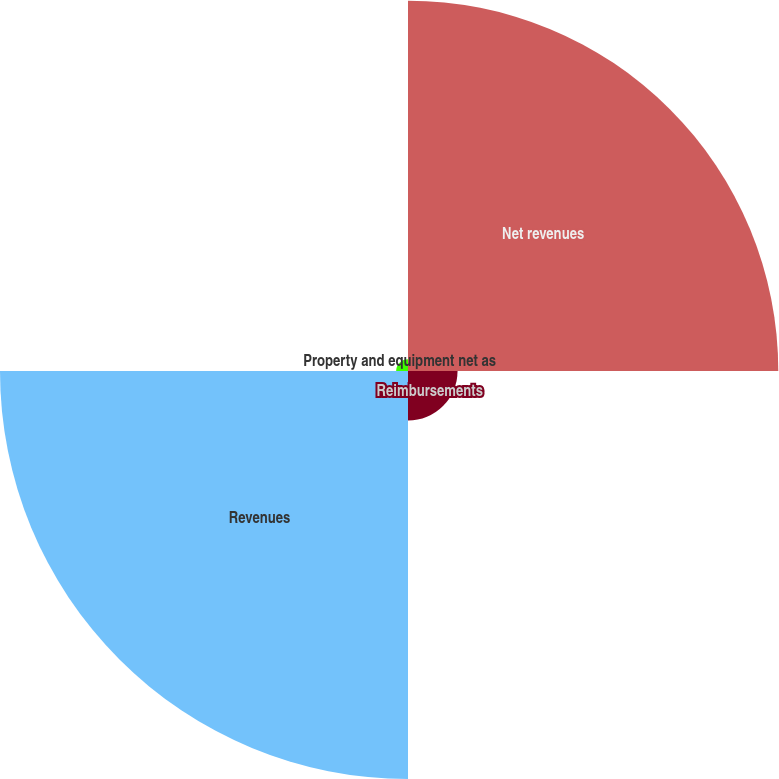Convert chart. <chart><loc_0><loc_0><loc_500><loc_500><pie_chart><fcel>Net revenues<fcel>Reimbursements<fcel>Revenues<fcel>Property and equipment net as<nl><fcel>44.1%<fcel>5.9%<fcel>48.59%<fcel>1.41%<nl></chart> 